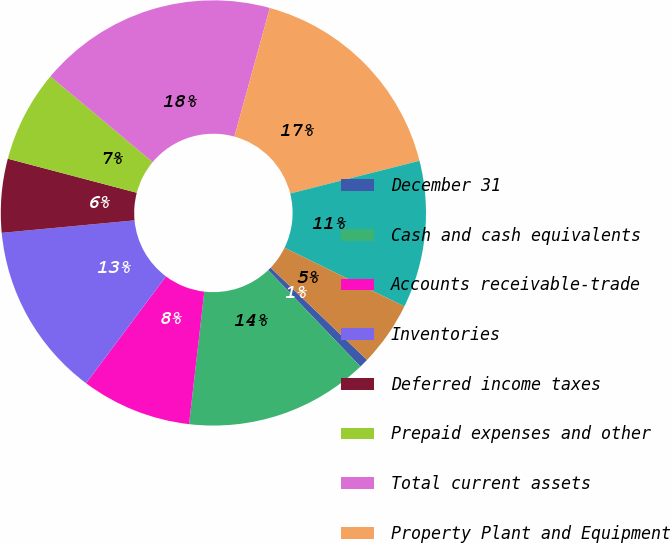Convert chart to OTSL. <chart><loc_0><loc_0><loc_500><loc_500><pie_chart><fcel>December 31<fcel>Cash and cash equivalents<fcel>Accounts receivable-trade<fcel>Inventories<fcel>Deferred income taxes<fcel>Prepaid expenses and other<fcel>Total current assets<fcel>Property Plant and Equipment<fcel>Goodwill<fcel>Other Intangibles<nl><fcel>0.7%<fcel>13.98%<fcel>8.39%<fcel>13.29%<fcel>5.6%<fcel>6.99%<fcel>18.18%<fcel>16.78%<fcel>11.19%<fcel>4.9%<nl></chart> 